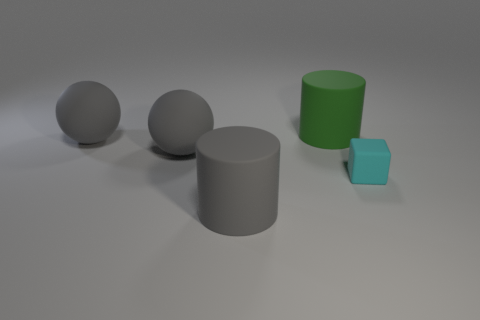There is another object that is the same shape as the green object; what size is it?
Offer a very short reply. Large. How many balls have the same material as the small cyan block?
Give a very brief answer. 2. Is the material of the big thing that is in front of the tiny cyan matte object the same as the tiny cyan cube?
Your response must be concise. Yes. Are there an equal number of cyan matte objects right of the small cyan rubber block and big gray objects?
Give a very brief answer. No. What is the size of the cyan block?
Make the answer very short. Small. What number of other matte cubes have the same color as the tiny rubber cube?
Your answer should be very brief. 0. Do the cyan matte block and the green object have the same size?
Make the answer very short. No. There is a cylinder that is to the right of the big gray thing that is in front of the rubber cube; what is its size?
Make the answer very short. Large. There is a matte cube; does it have the same color as the cylinder in front of the big green matte cylinder?
Ensure brevity in your answer.  No. Is there a red shiny cylinder that has the same size as the cube?
Your answer should be compact. No. 